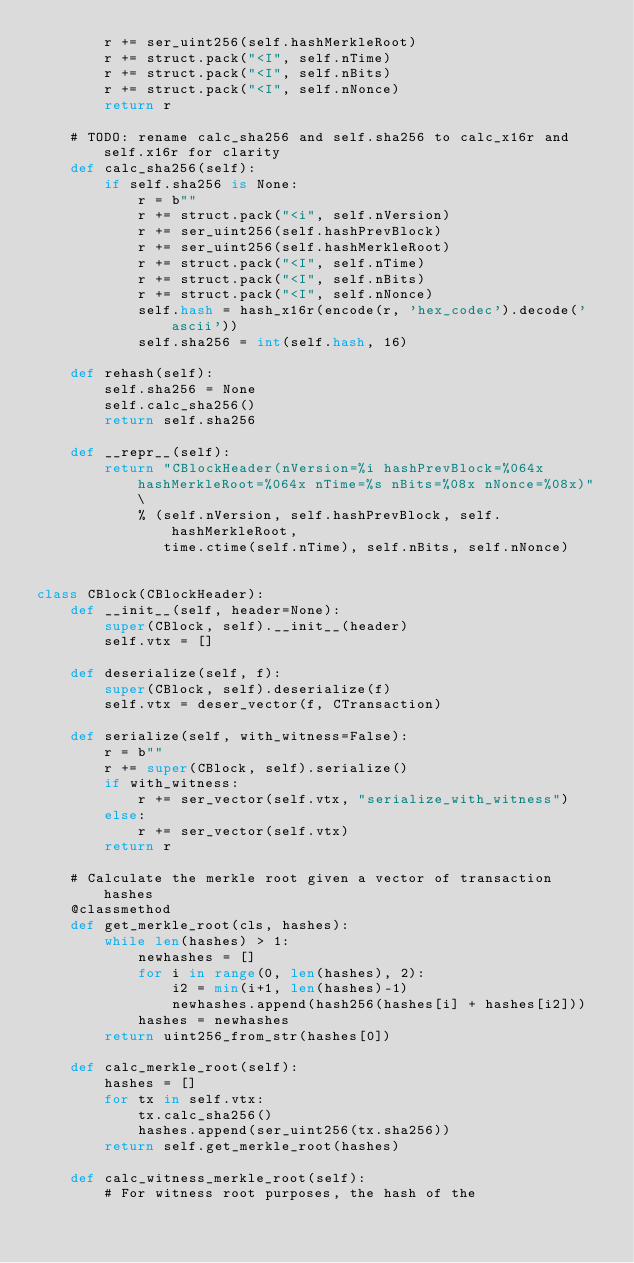Convert code to text. <code><loc_0><loc_0><loc_500><loc_500><_Python_>        r += ser_uint256(self.hashMerkleRoot)
        r += struct.pack("<I", self.nTime)
        r += struct.pack("<I", self.nBits)
        r += struct.pack("<I", self.nNonce)
        return r

    # TODO: rename calc_sha256 and self.sha256 to calc_x16r and self.x16r for clarity
    def calc_sha256(self):
        if self.sha256 is None:
            r = b""
            r += struct.pack("<i", self.nVersion)
            r += ser_uint256(self.hashPrevBlock)
            r += ser_uint256(self.hashMerkleRoot)
            r += struct.pack("<I", self.nTime)
            r += struct.pack("<I", self.nBits)
            r += struct.pack("<I", self.nNonce)
            self.hash = hash_x16r(encode(r, 'hex_codec').decode('ascii'))
            self.sha256 = int(self.hash, 16)

    def rehash(self):
        self.sha256 = None
        self.calc_sha256()
        return self.sha256

    def __repr__(self):
        return "CBlockHeader(nVersion=%i hashPrevBlock=%064x hashMerkleRoot=%064x nTime=%s nBits=%08x nNonce=%08x)" \
            % (self.nVersion, self.hashPrevBlock, self.hashMerkleRoot,
               time.ctime(self.nTime), self.nBits, self.nNonce)


class CBlock(CBlockHeader):
    def __init__(self, header=None):
        super(CBlock, self).__init__(header)
        self.vtx = []

    def deserialize(self, f):
        super(CBlock, self).deserialize(f)
        self.vtx = deser_vector(f, CTransaction)

    def serialize(self, with_witness=False):
        r = b""
        r += super(CBlock, self).serialize()
        if with_witness:
            r += ser_vector(self.vtx, "serialize_with_witness")
        else:
            r += ser_vector(self.vtx)
        return r

    # Calculate the merkle root given a vector of transaction hashes
    @classmethod
    def get_merkle_root(cls, hashes):
        while len(hashes) > 1:
            newhashes = []
            for i in range(0, len(hashes), 2):
                i2 = min(i+1, len(hashes)-1)
                newhashes.append(hash256(hashes[i] + hashes[i2]))
            hashes = newhashes
        return uint256_from_str(hashes[0])

    def calc_merkle_root(self):
        hashes = []
        for tx in self.vtx:
            tx.calc_sha256()
            hashes.append(ser_uint256(tx.sha256))
        return self.get_merkle_root(hashes)

    def calc_witness_merkle_root(self):
        # For witness root purposes, the hash of the</code> 